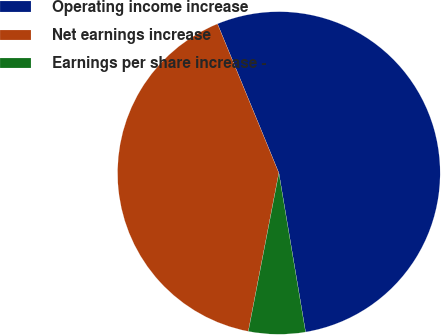<chart> <loc_0><loc_0><loc_500><loc_500><pie_chart><fcel>Operating income increase<fcel>Net earnings increase<fcel>Earnings per share increase -<nl><fcel>53.57%<fcel>40.76%<fcel>5.68%<nl></chart> 